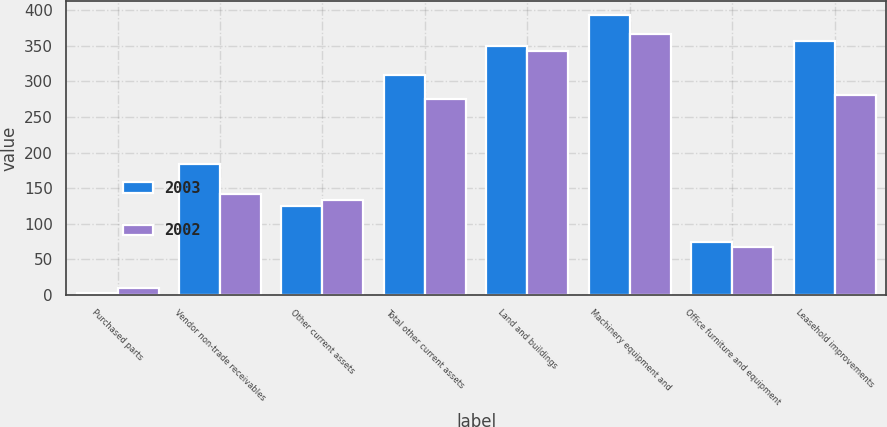Convert chart. <chart><loc_0><loc_0><loc_500><loc_500><stacked_bar_chart><ecel><fcel>Purchased parts<fcel>Vendor non-trade receivables<fcel>Other current assets<fcel>Total other current assets<fcel>Land and buildings<fcel>Machinery equipment and<fcel>Office furniture and equipment<fcel>Leasehold improvements<nl><fcel>2003<fcel>2<fcel>184<fcel>125<fcel>309<fcel>350<fcel>393<fcel>74<fcel>357<nl><fcel>2002<fcel>9<fcel>142<fcel>133<fcel>275<fcel>342<fcel>367<fcel>67<fcel>281<nl></chart> 